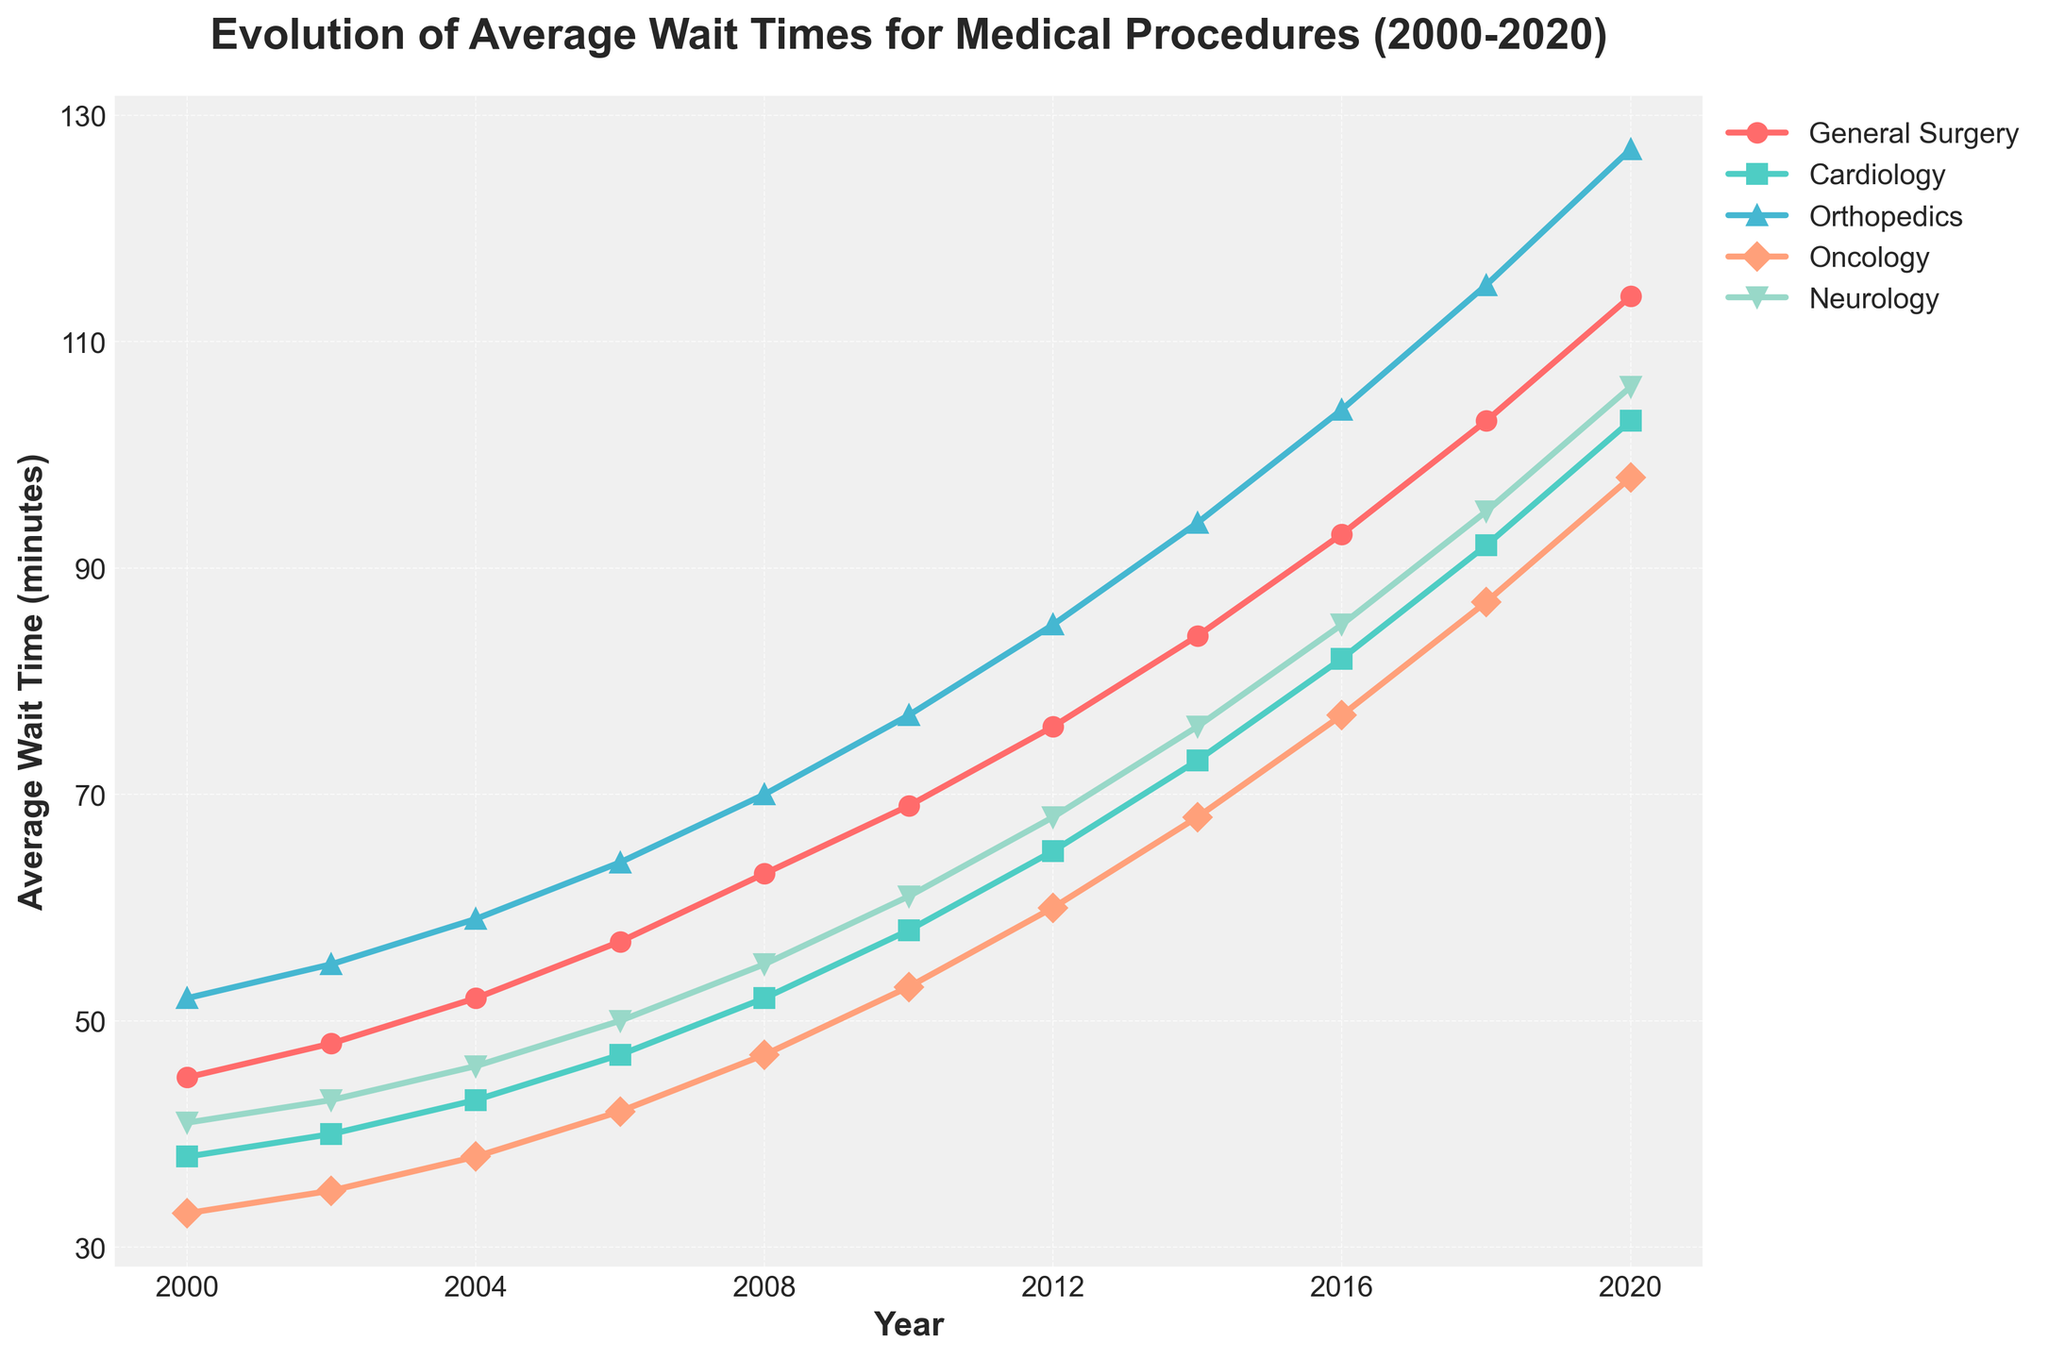Which year had the highest average wait time for General Surgery? To find the year with the highest wait time for General Surgery, look at the General Surgery line and find its peak. The peak value is 114 minutes in 2020.
Answer: 2020 Which procedure had the shortest wait time in 2000? Look at the data for different procedures in the year 2000 and identify the lowest value. The shortest wait time in 2000 is for Oncology at 33 minutes.
Answer: Oncology By how many minutes did the average wait time for Cardiology increase from 2000 to 2020? Subtract the average wait time for Cardiology in 2000 from the wait time in 2020: 103 - 38 = 65.
Answer: 65 Which procedure had a faster increase in wait times from 2006 to 2010: Orthopedics or Neurology? Calculate the increase for both procedures from 2006 to 2010. Orthopedics increased by 77 - 64 = 13, and Neurology increased by 61 - 50 = 11. Orthopedics had a faster increase.
Answer: Orthopedics What was the average wait time for Neurology across all years in the dataset? Add the wait times for Neurology across all years and divide by the number of years: (41 + 43 + 46 + 50 + 55 + 61 + 68 + 76 + 85 + 95 + 106) / 11 = 61.
Answer: 61 Compare the wait time trends for General Surgery and Oncology. Which one had a steeper increase? Calculate the slope for both lines. General Surgery increased from 45 to 114 (69 minutes), and Oncology increased from 33 to 98 (65 minutes). General Surgery had a steeper increase.
Answer: General Surgery Which procedure had the most significant wait time increase between 2010 and 2018? Look at the differences in wait times between 2010 and 2018 for all procedures and identify the largest: General Surgery increased by 103 - 69 = 34, Cardiology by 92 - 58 = 34, Orthopedics by 115 - 77 = 38, Oncology by 87 - 53 = 34, Neurology by 95 - 61 = 34. Orthopedics had the most significant increase.
Answer: Orthopedics How did the wait time for General Surgery change from 2000 to 2010? Find the wait times for General Surgery in 2000 and 2010 and calculate the change: 69 - 45 = 24 minutes increase.
Answer: Increased by 24 minutes Which procedure had the most consistent increase in wait times over the years? Compare the trends for all procedures; consistent increase means a steady upward trend without fluctuations. General Surgery appears most consistent.
Answer: General Surgery By how much did the average wait time for Neurology change between 2008 and 2016? Subtract the average wait time for Neurology in 2008 from 2016: 85 - 55 = 30.
Answer: 30 